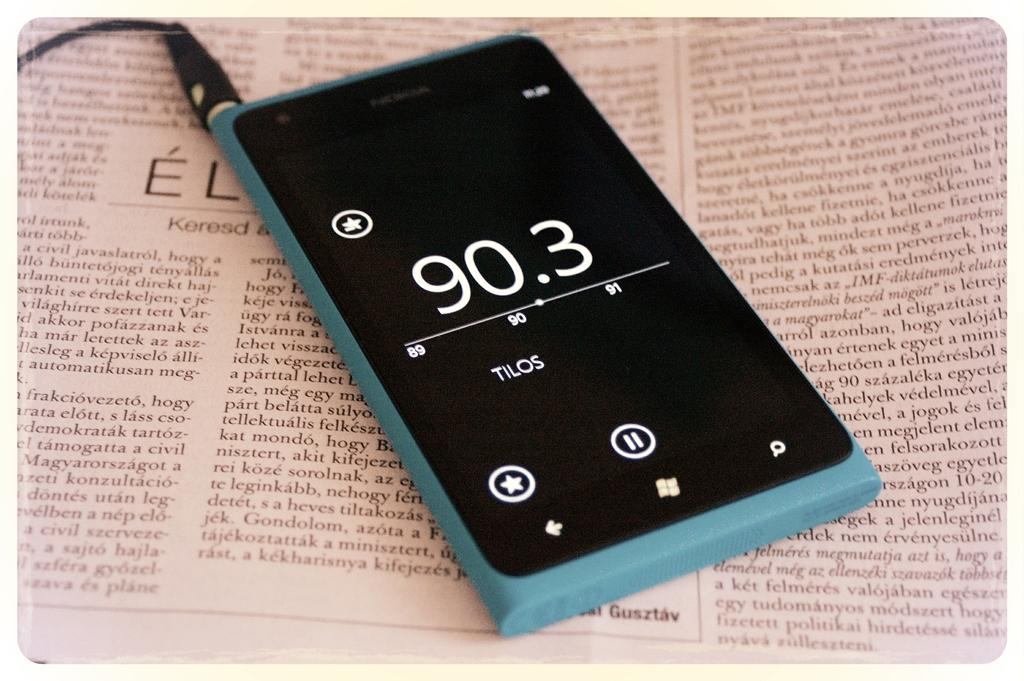What electronic device is visible in the image? There is a mobile phone in the image. How is the mobile phone connected to something else in the image? A wire is connected to the mobile phone. What type of printed material is at the bottom of the image? There is a newspaper at the bottom of the image. Where is the faucet located in the image? There is no faucet present in the image. What type of camera is being used to take the picture? The facts provided do not mention a camera being used to take the picture, so we cannot determine the type of camera. 